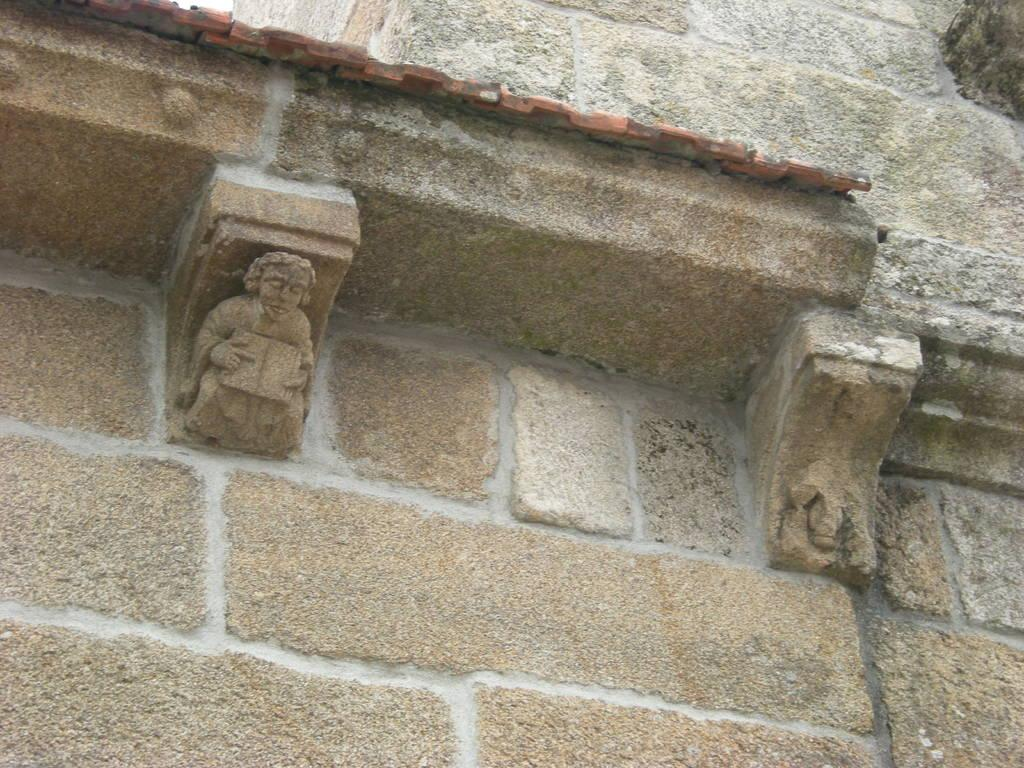What is present on the wall in the image? There are sculptures on the wall in the image. What type of zebra can be seen performing a trick on the wall in the image? There is no zebra present in the image, and no tricks are being performed. 